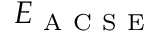<formula> <loc_0><loc_0><loc_500><loc_500>E _ { A C S E }</formula> 